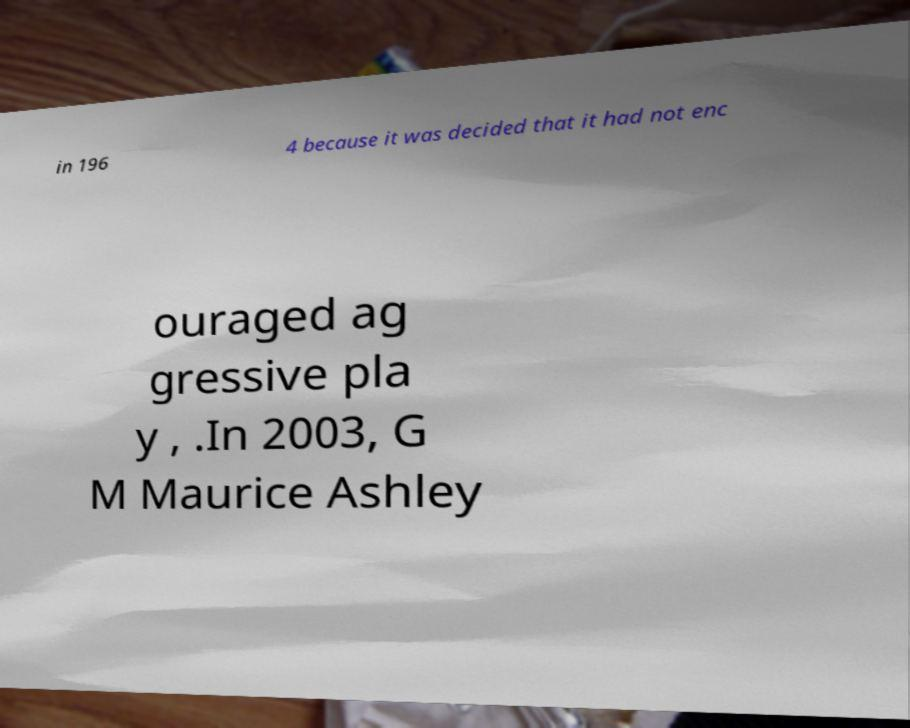Could you extract and type out the text from this image? in 196 4 because it was decided that it had not enc ouraged ag gressive pla y , .In 2003, G M Maurice Ashley 